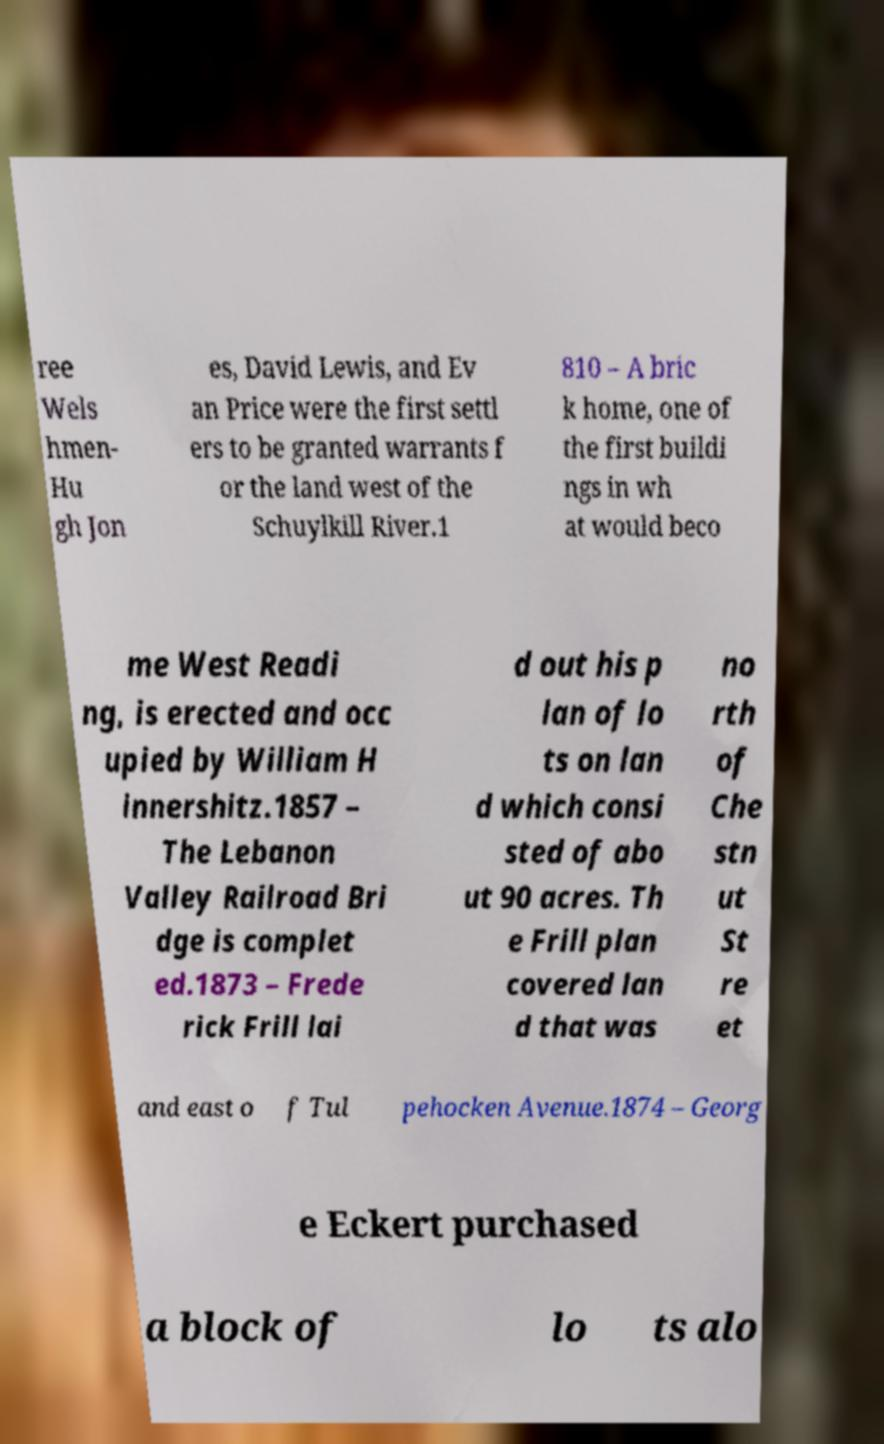Could you extract and type out the text from this image? ree Wels hmen- Hu gh Jon es, David Lewis, and Ev an Price were the first settl ers to be granted warrants f or the land west of the Schuylkill River.1 810 – A bric k home, one of the first buildi ngs in wh at would beco me West Readi ng, is erected and occ upied by William H innershitz.1857 – The Lebanon Valley Railroad Bri dge is complet ed.1873 – Frede rick Frill lai d out his p lan of lo ts on lan d which consi sted of abo ut 90 acres. Th e Frill plan covered lan d that was no rth of Che stn ut St re et and east o f Tul pehocken Avenue.1874 – Georg e Eckert purchased a block of lo ts alo 